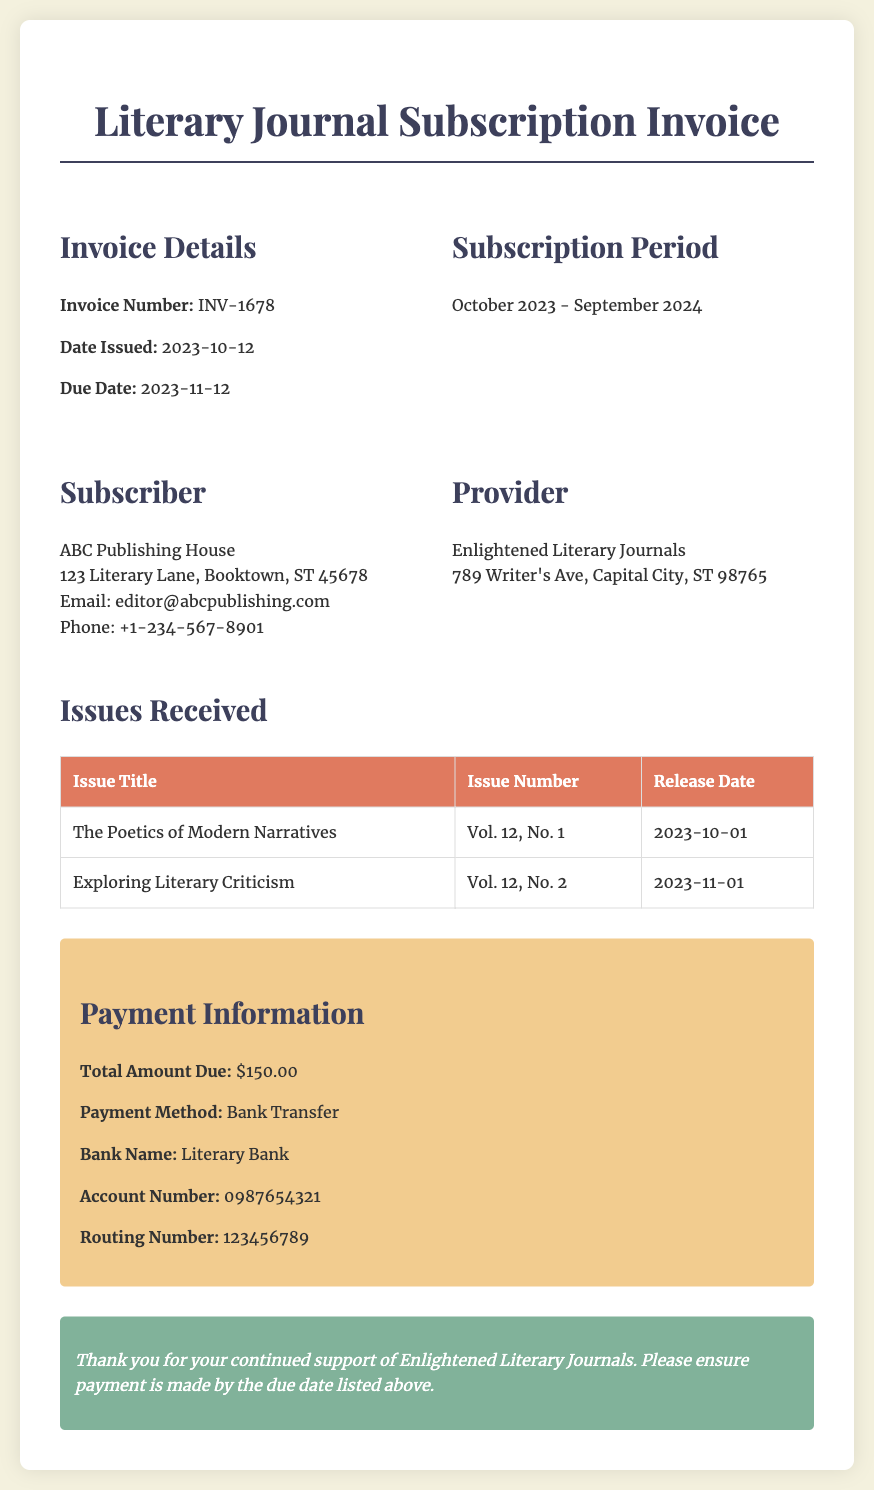What is the invoice number? The invoice number is prominently displayed in the Invoice Details section of the document.
Answer: INV-1678 When was the invoice issued? The date issued is clearly noted in the Invoice Details section.
Answer: 2023-10-12 What is the total amount due? The total amount due is found in the Payment Information section.
Answer: $150.00 Which issues have been received? The Issues Received table lists the titles and details of the issues.
Answer: The Poetics of Modern Narratives; Vol. 12, No. 1; 2023-10-01; Exploring Literary Criticism; Vol. 12, No. 2; 2023-11-01 What is the payment method specified? The payment method is outlined in the Payment Information section.
Answer: Bank Transfer What is the subscription period? The subscription period is noted directly under the Subscription Period heading.
Answer: October 2023 - September 2024 Who is the provider of the literary journals? The provider's name is presented in the section that describes the Provider.
Answer: Enlightened Literary Journals What is the due date for payment? The due date is listed in the Invoice Details section.
Answer: 2023-11-12 What bank is the payment method associated with? The bank name is mentioned in the Payment Information section.
Answer: Literary Bank 